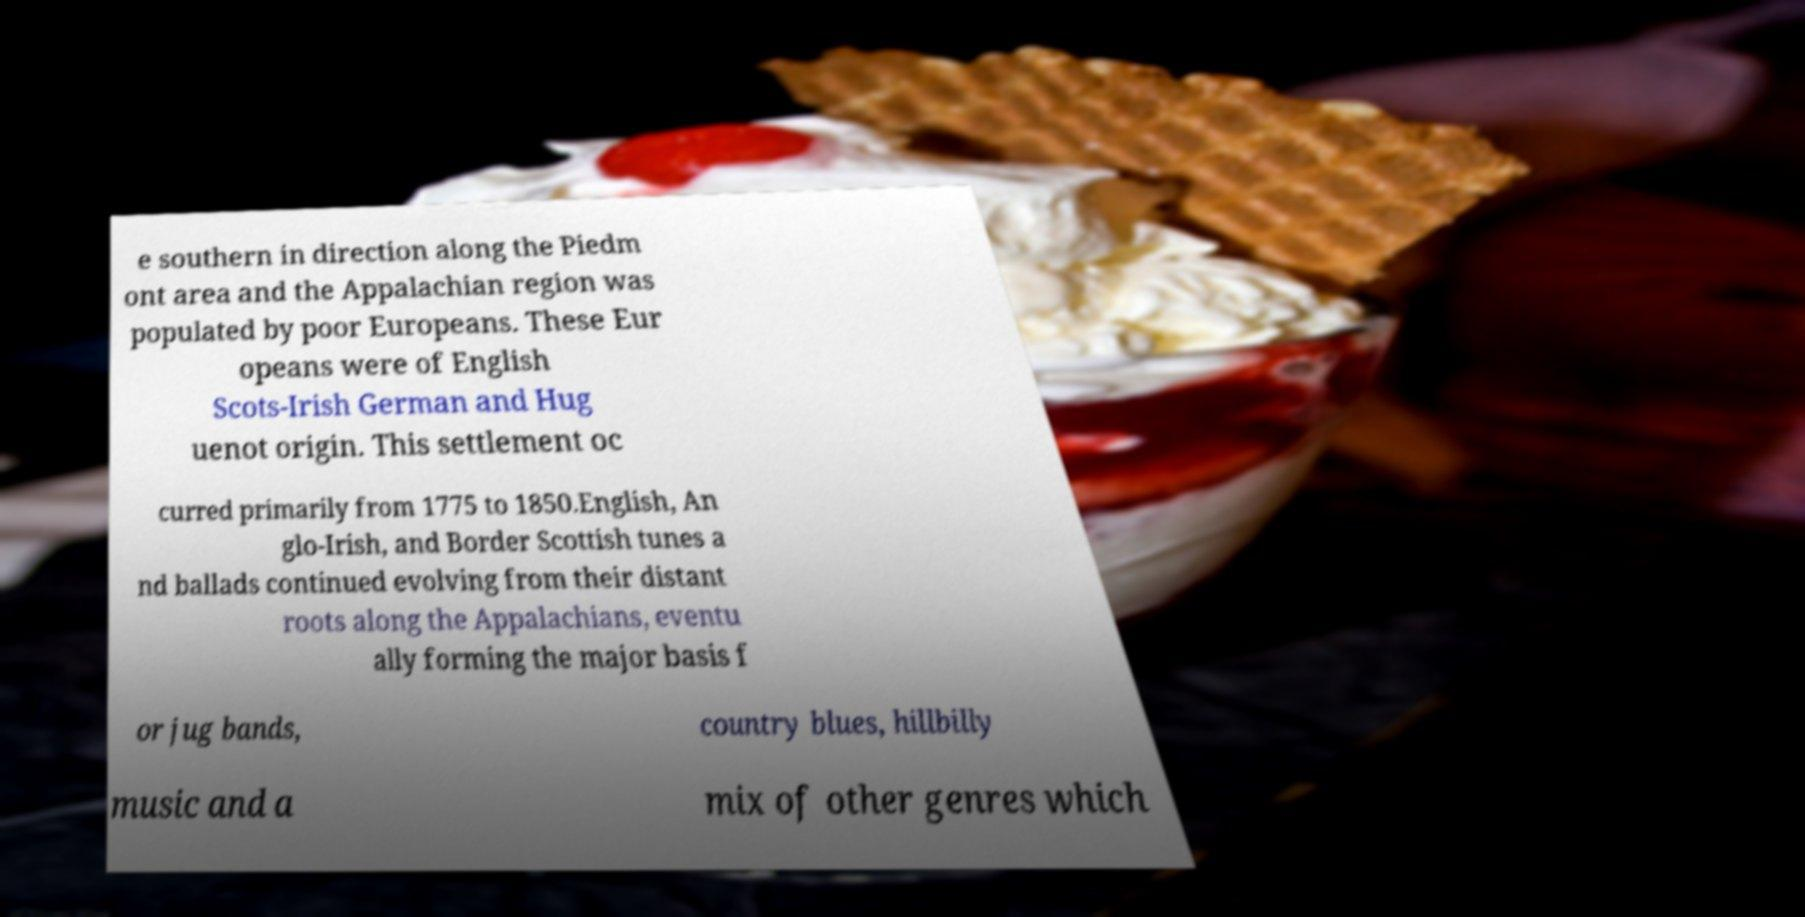Could you assist in decoding the text presented in this image and type it out clearly? e southern in direction along the Piedm ont area and the Appalachian region was populated by poor Europeans. These Eur opeans were of English Scots-Irish German and Hug uenot origin. This settlement oc curred primarily from 1775 to 1850.English, An glo-Irish, and Border Scottish tunes a nd ballads continued evolving from their distant roots along the Appalachians, eventu ally forming the major basis f or jug bands, country blues, hillbilly music and a mix of other genres which 